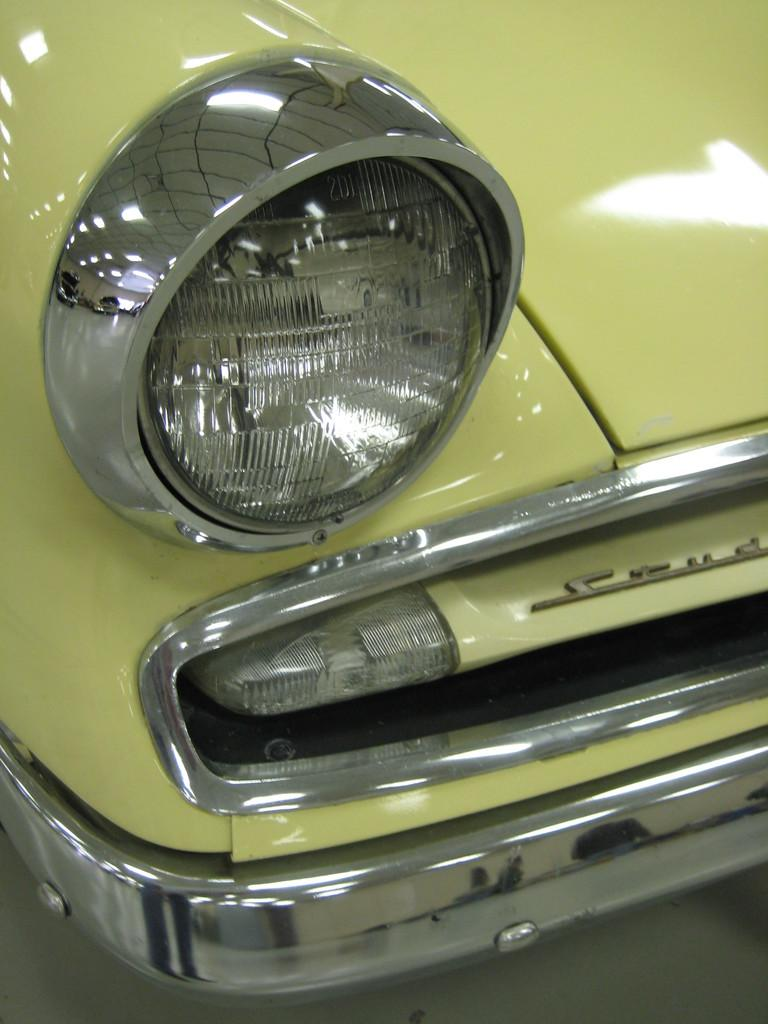What is the main subject of the image? The main subject of the image is a headlight of a car. Can you describe the color of the car? The car is green in color. What type of stamp can be seen on the stage in the image? There is no stage, crime, or stamp present in the image. The image only features a headlight of a car. 